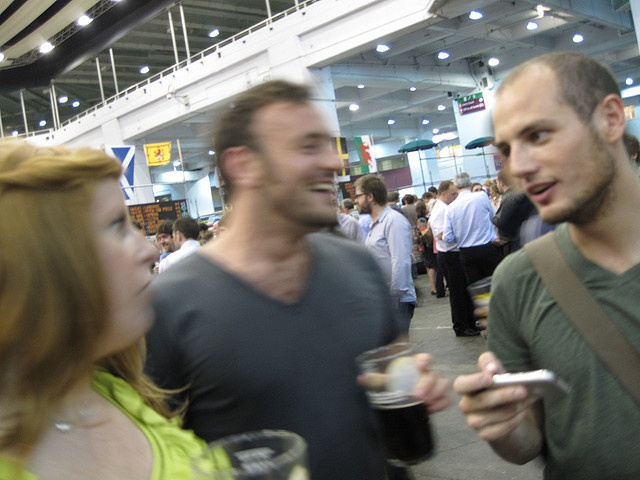Describe the objects in this image and their specific colors. I can see people in darkgray, black, gray, and darkblue tones, people in darkgray, gray, and black tones, people in darkgray, olive, and black tones, people in darkgray, gray, and lavender tones, and cup in darkgray, gray, black, and olive tones in this image. 